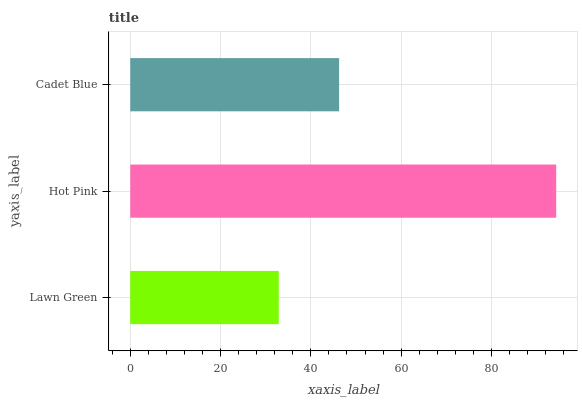Is Lawn Green the minimum?
Answer yes or no. Yes. Is Hot Pink the maximum?
Answer yes or no. Yes. Is Cadet Blue the minimum?
Answer yes or no. No. Is Cadet Blue the maximum?
Answer yes or no. No. Is Hot Pink greater than Cadet Blue?
Answer yes or no. Yes. Is Cadet Blue less than Hot Pink?
Answer yes or no. Yes. Is Cadet Blue greater than Hot Pink?
Answer yes or no. No. Is Hot Pink less than Cadet Blue?
Answer yes or no. No. Is Cadet Blue the high median?
Answer yes or no. Yes. Is Cadet Blue the low median?
Answer yes or no. Yes. Is Lawn Green the high median?
Answer yes or no. No. Is Lawn Green the low median?
Answer yes or no. No. 